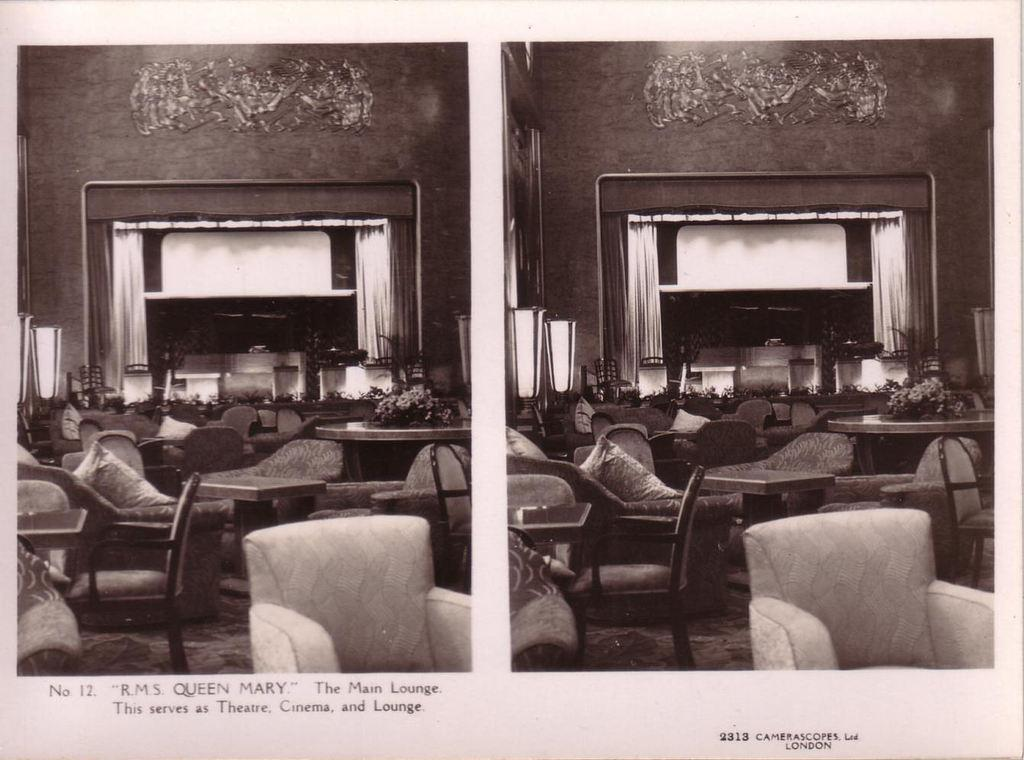What objects are arranged in a group in the image? There is a group of chairs in the image. What can be seen in the background of the image? There is a curtain in the background of the image. What type of insect can be seen crawling on the curtain in the image? A: There is no insect visible on the curtain in the image. 